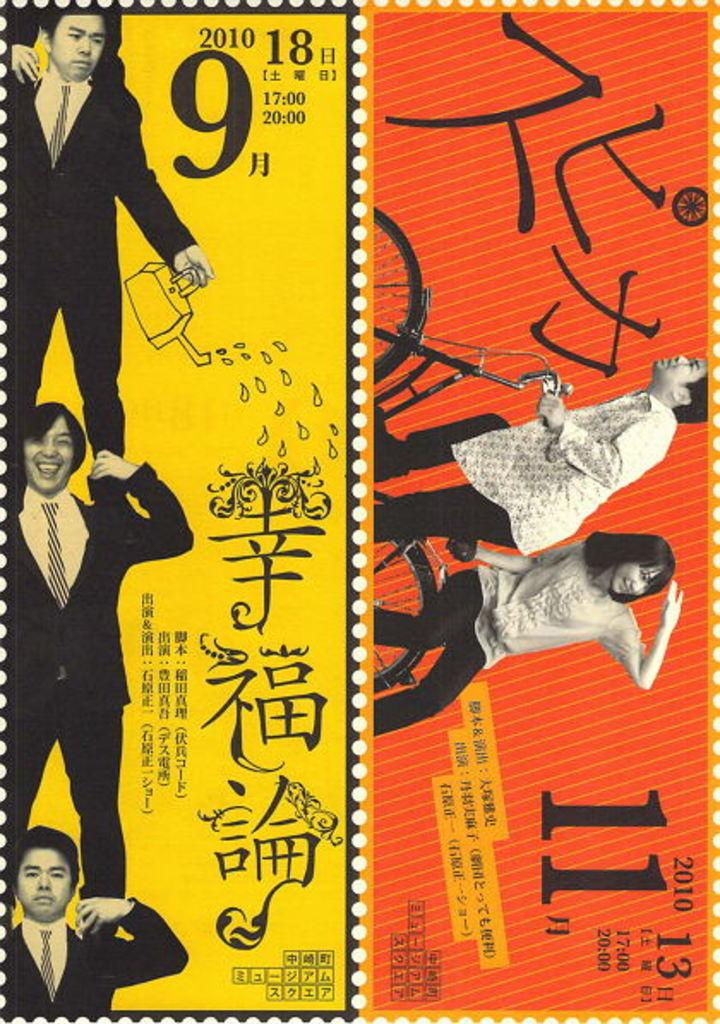Provide a one-sentence caption for the provided image. Three men stand on top of each others shoulders with a large 9 next to the top one. 